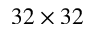<formula> <loc_0><loc_0><loc_500><loc_500>3 2 \times 3 2</formula> 